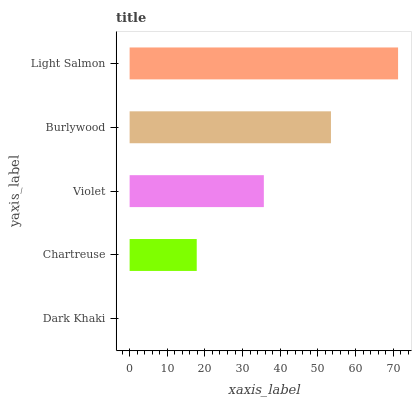Is Dark Khaki the minimum?
Answer yes or no. Yes. Is Light Salmon the maximum?
Answer yes or no. Yes. Is Chartreuse the minimum?
Answer yes or no. No. Is Chartreuse the maximum?
Answer yes or no. No. Is Chartreuse greater than Dark Khaki?
Answer yes or no. Yes. Is Dark Khaki less than Chartreuse?
Answer yes or no. Yes. Is Dark Khaki greater than Chartreuse?
Answer yes or no. No. Is Chartreuse less than Dark Khaki?
Answer yes or no. No. Is Violet the high median?
Answer yes or no. Yes. Is Violet the low median?
Answer yes or no. Yes. Is Burlywood the high median?
Answer yes or no. No. Is Chartreuse the low median?
Answer yes or no. No. 